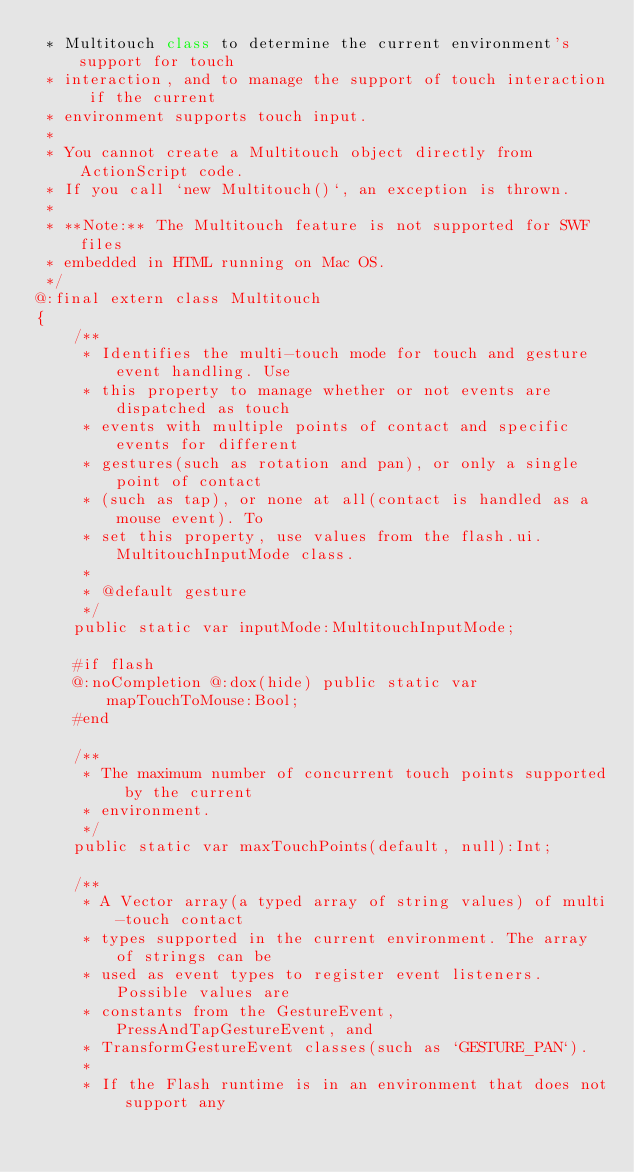<code> <loc_0><loc_0><loc_500><loc_500><_Haxe_> * Multitouch class to determine the current environment's support for touch
 * interaction, and to manage the support of touch interaction if the current
 * environment supports touch input.
 *
 * You cannot create a Multitouch object directly from ActionScript code.
 * If you call `new Multitouch()`, an exception is thrown.
 *
 * **Note:** The Multitouch feature is not supported for SWF files
 * embedded in HTML running on Mac OS.
 */
@:final extern class Multitouch
{
	/**
	 * Identifies the multi-touch mode for touch and gesture event handling. Use
	 * this property to manage whether or not events are dispatched as touch
	 * events with multiple points of contact and specific events for different
	 * gestures(such as rotation and pan), or only a single point of contact
	 * (such as tap), or none at all(contact is handled as a mouse event). To
	 * set this property, use values from the flash.ui.MultitouchInputMode class.
	 *
	 * @default gesture
	 */
	public static var inputMode:MultitouchInputMode;

	#if flash
	@:noCompletion @:dox(hide) public static var mapTouchToMouse:Bool;
	#end

	/**
	 * The maximum number of concurrent touch points supported by the current
	 * environment.
	 */
	public static var maxTouchPoints(default, null):Int;

	/**
	 * A Vector array(a typed array of string values) of multi-touch contact
	 * types supported in the current environment. The array of strings can be
	 * used as event types to register event listeners. Possible values are
	 * constants from the GestureEvent, PressAndTapGestureEvent, and
	 * TransformGestureEvent classes(such as `GESTURE_PAN`).
	 *
	 * If the Flash runtime is in an environment that does not support any</code> 